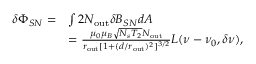<formula> <loc_0><loc_0><loc_500><loc_500>\begin{array} { r l } { \delta \Phi _ { S N } = } & { \int 2 N _ { o u t } \delta B _ { S N } d A } \\ & { = \frac { \mu _ { 0 } \mu _ { B } \sqrt { N _ { s } T _ { 2 } } N _ { o u t } } { r _ { o u t } [ 1 + ( d / r _ { o u t } ) ^ { 2 } ] ^ { 3 / 2 } } L ( \nu - \nu _ { 0 } , \delta \nu ) , } \end{array}</formula> 